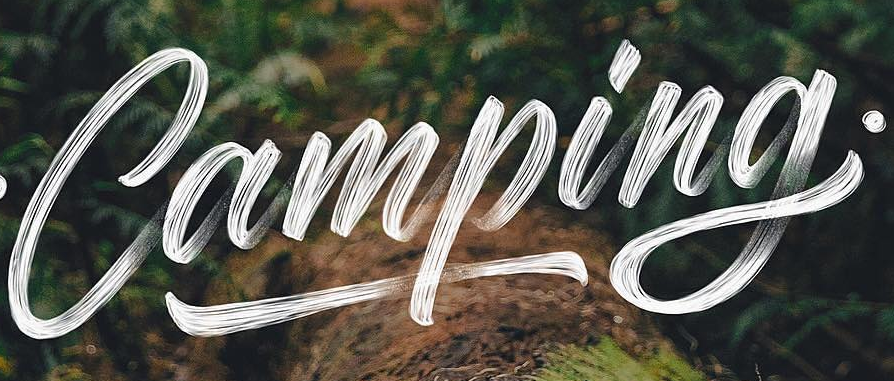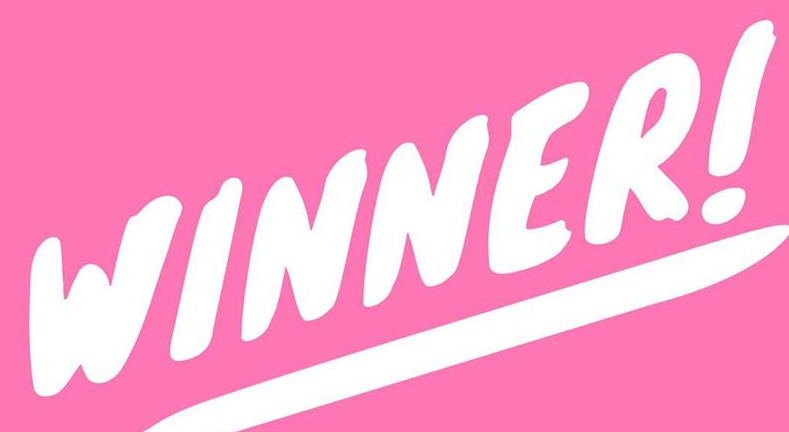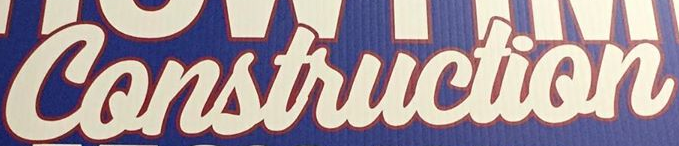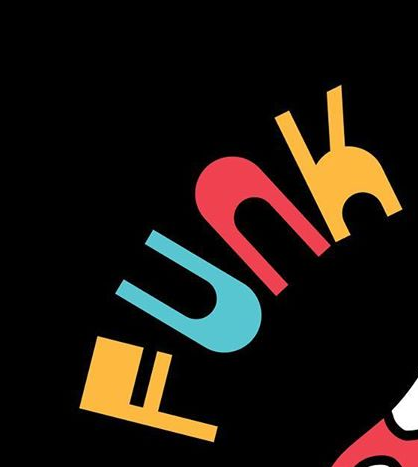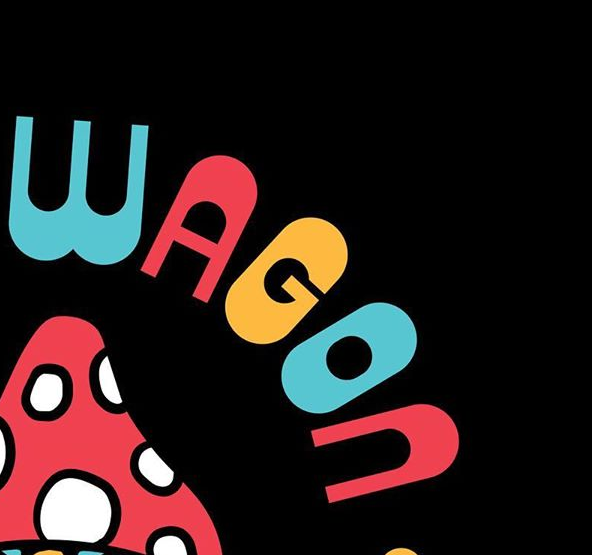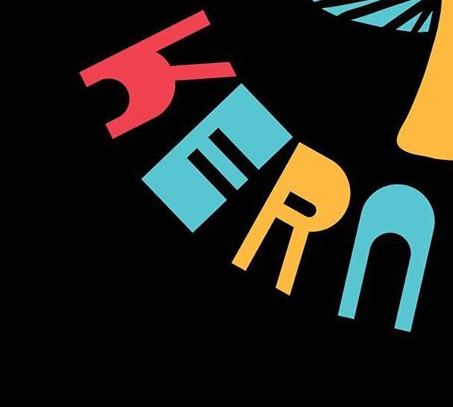Identify the words shown in these images in order, separated by a semicolon. Camping; WINNER!; Construction; FUNK; WAGON; KERN 